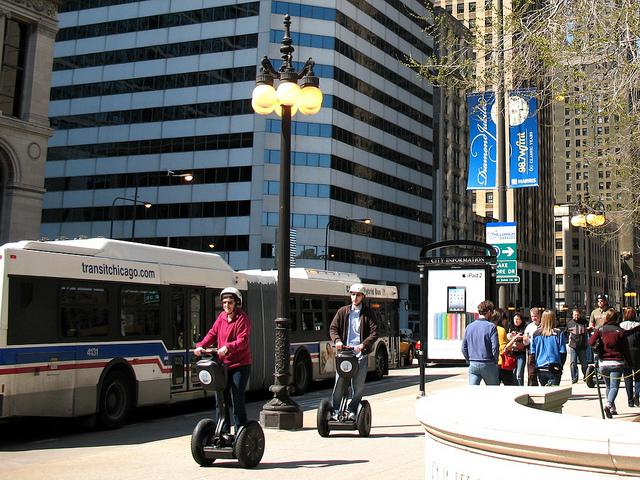What are the riders riding?
Give a very brief answer. Segway. What city are these people in?
Give a very brief answer. Chicago. Why are they riding on the street?
Keep it brief. Segways. 